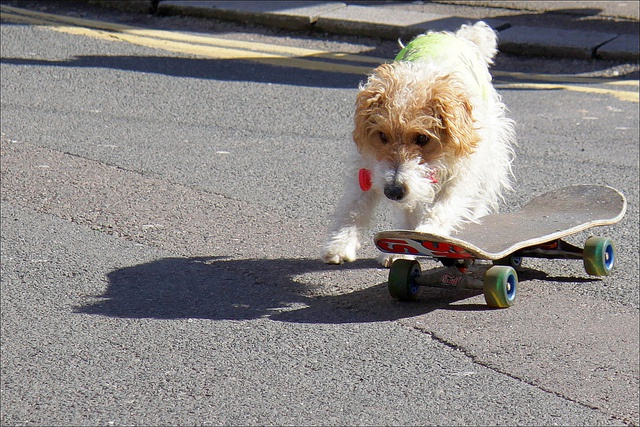Describe the objects in this image and their specific colors. I can see dog in black, ivory, darkgray, tan, and gray tones and skateboard in black, darkgray, lightgray, and gray tones in this image. 